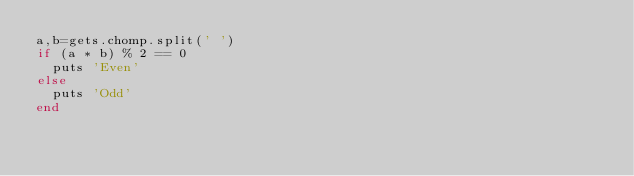Convert code to text. <code><loc_0><loc_0><loc_500><loc_500><_Ruby_>a,b=gets.chomp.split(' ')
if (a * b) % 2 == 0
  puts 'Even'
else
  puts 'Odd'
end</code> 